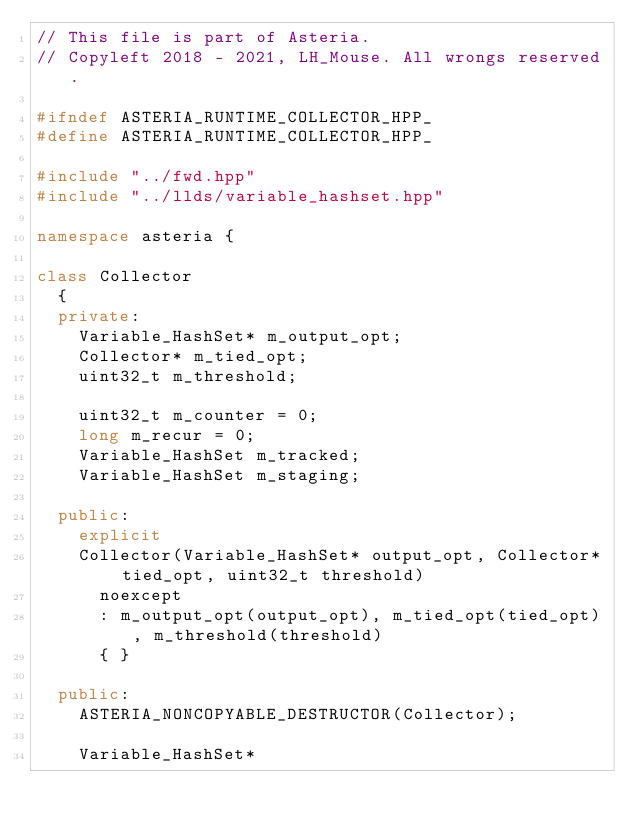Convert code to text. <code><loc_0><loc_0><loc_500><loc_500><_C++_>// This file is part of Asteria.
// Copyleft 2018 - 2021, LH_Mouse. All wrongs reserved.

#ifndef ASTERIA_RUNTIME_COLLECTOR_HPP_
#define ASTERIA_RUNTIME_COLLECTOR_HPP_

#include "../fwd.hpp"
#include "../llds/variable_hashset.hpp"

namespace asteria {

class Collector
  {
  private:
    Variable_HashSet* m_output_opt;
    Collector* m_tied_opt;
    uint32_t m_threshold;

    uint32_t m_counter = 0;
    long m_recur = 0;
    Variable_HashSet m_tracked;
    Variable_HashSet m_staging;

  public:
    explicit
    Collector(Variable_HashSet* output_opt, Collector* tied_opt, uint32_t threshold)
      noexcept
      : m_output_opt(output_opt), m_tied_opt(tied_opt), m_threshold(threshold)
      { }

  public:
    ASTERIA_NONCOPYABLE_DESTRUCTOR(Collector);

    Variable_HashSet*</code> 